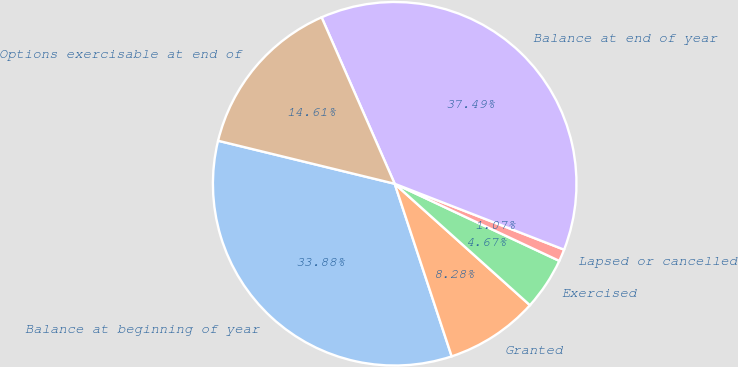Convert chart to OTSL. <chart><loc_0><loc_0><loc_500><loc_500><pie_chart><fcel>Balance at beginning of year<fcel>Granted<fcel>Exercised<fcel>Lapsed or cancelled<fcel>Balance at end of year<fcel>Options exercisable at end of<nl><fcel>33.88%<fcel>8.28%<fcel>4.67%<fcel>1.07%<fcel>37.49%<fcel>14.61%<nl></chart> 